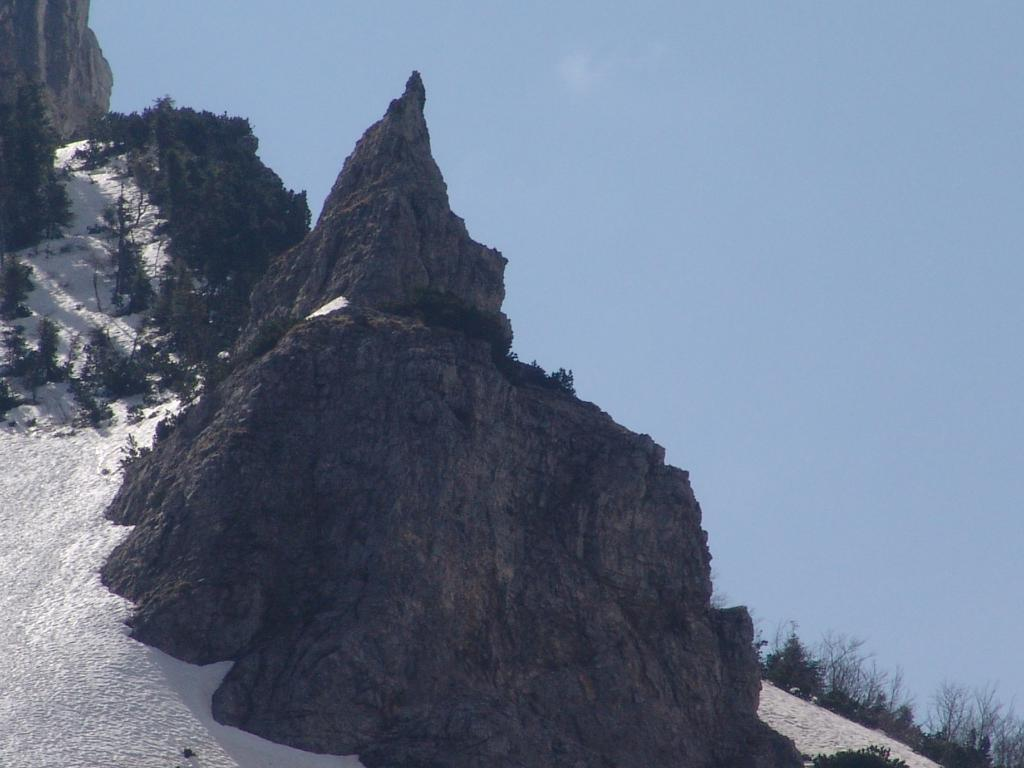What is located in the foreground of the image? There is a cliff, snow, and trees in the foreground of the image. What type of vegetation can be seen in the foreground of the image? Trees can be seen in the foreground of the image. What is visible in the background of the image? There are trees and the sky visible in the background of the image. What type of fruit is hanging from the trees in the image? There is no fruit visible in the image; only trees, snow, and a cliff are present. Can you see a duck swimming in the snow in the image? There is no duck present in the image; it features a cliff, snow, and trees. 